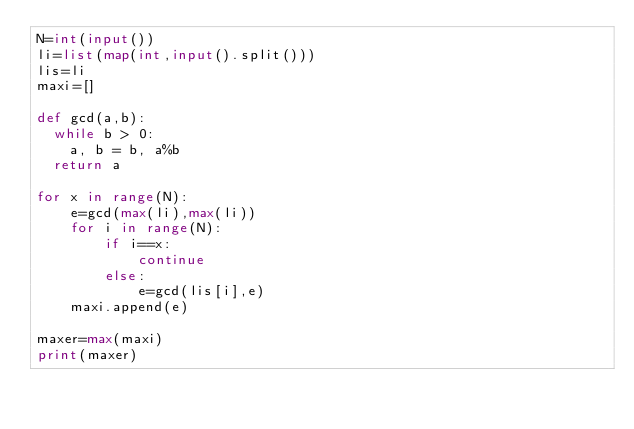<code> <loc_0><loc_0><loc_500><loc_500><_Python_>N=int(input())
li=list(map(int,input().split()))
lis=li
maxi=[]

def gcd(a,b):
  while b > 0:
    a, b = b, a%b
  return a

for x in range(N):
    e=gcd(max(li),max(li))
    for i in range(N):
        if i==x:
            continue
        else:
            e=gcd(lis[i],e)
    maxi.append(e)

maxer=max(maxi)
print(maxer)</code> 